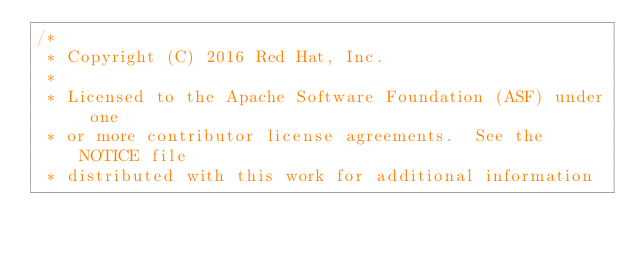Convert code to text. <code><loc_0><loc_0><loc_500><loc_500><_Go_>/*
 * Copyright (C) 2016 Red Hat, Inc.
 *
 * Licensed to the Apache Software Foundation (ASF) under one
 * or more contributor license agreements.  See the NOTICE file
 * distributed with this work for additional information</code> 